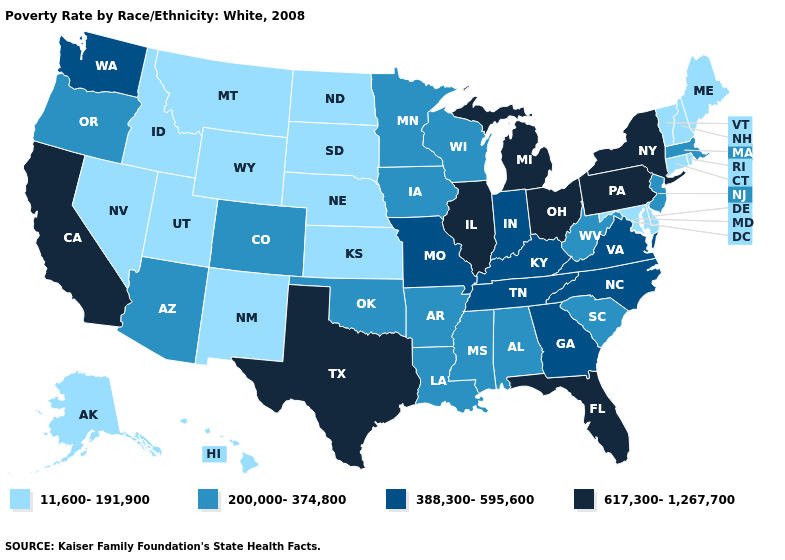What is the value of West Virginia?
Give a very brief answer. 200,000-374,800. Does South Carolina have a lower value than Connecticut?
Give a very brief answer. No. Among the states that border Kansas , does Missouri have the highest value?
Short answer required. Yes. Which states have the lowest value in the USA?
Write a very short answer. Alaska, Connecticut, Delaware, Hawaii, Idaho, Kansas, Maine, Maryland, Montana, Nebraska, Nevada, New Hampshire, New Mexico, North Dakota, Rhode Island, South Dakota, Utah, Vermont, Wyoming. Name the states that have a value in the range 617,300-1,267,700?
Short answer required. California, Florida, Illinois, Michigan, New York, Ohio, Pennsylvania, Texas. Which states have the lowest value in the USA?
Quick response, please. Alaska, Connecticut, Delaware, Hawaii, Idaho, Kansas, Maine, Maryland, Montana, Nebraska, Nevada, New Hampshire, New Mexico, North Dakota, Rhode Island, South Dakota, Utah, Vermont, Wyoming. What is the value of West Virginia?
Give a very brief answer. 200,000-374,800. What is the value of North Carolina?
Give a very brief answer. 388,300-595,600. What is the value of New York?
Be succinct. 617,300-1,267,700. Name the states that have a value in the range 11,600-191,900?
Keep it brief. Alaska, Connecticut, Delaware, Hawaii, Idaho, Kansas, Maine, Maryland, Montana, Nebraska, Nevada, New Hampshire, New Mexico, North Dakota, Rhode Island, South Dakota, Utah, Vermont, Wyoming. Name the states that have a value in the range 11,600-191,900?
Concise answer only. Alaska, Connecticut, Delaware, Hawaii, Idaho, Kansas, Maine, Maryland, Montana, Nebraska, Nevada, New Hampshire, New Mexico, North Dakota, Rhode Island, South Dakota, Utah, Vermont, Wyoming. What is the value of Nevada?
Be succinct. 11,600-191,900. Among the states that border Nevada , which have the lowest value?
Give a very brief answer. Idaho, Utah. Does West Virginia have a higher value than Michigan?
Concise answer only. No. 